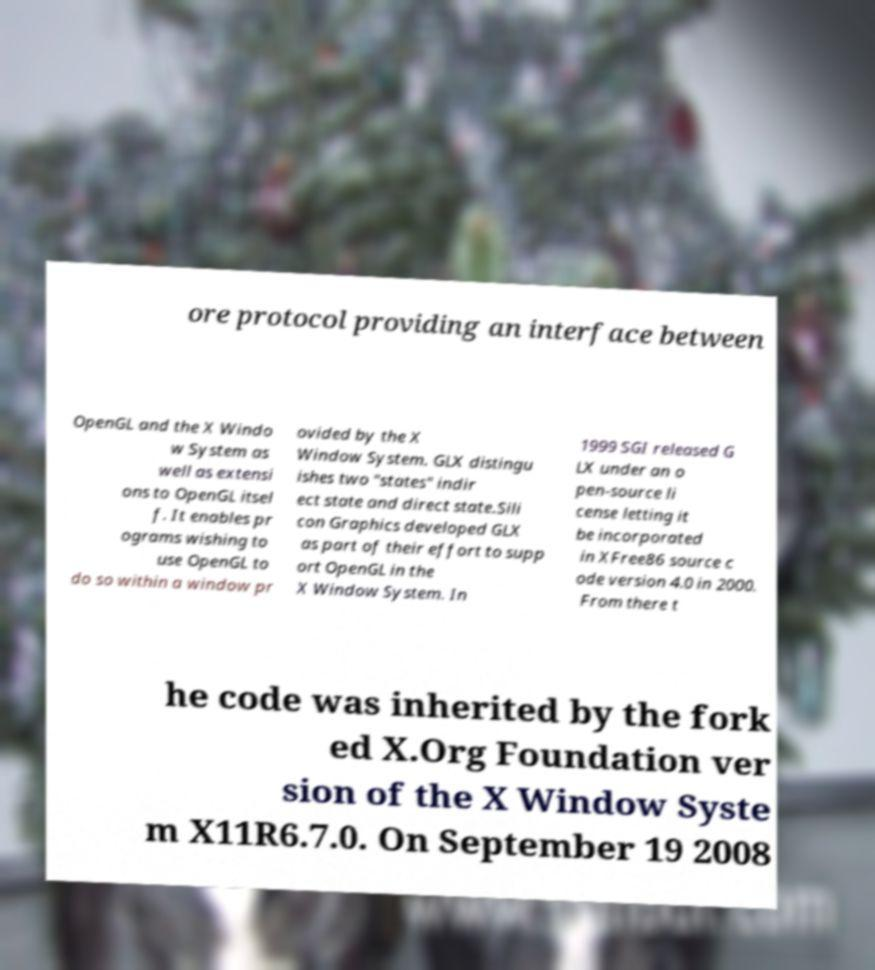What messages or text are displayed in this image? I need them in a readable, typed format. ore protocol providing an interface between OpenGL and the X Windo w System as well as extensi ons to OpenGL itsel f. It enables pr ograms wishing to use OpenGL to do so within a window pr ovided by the X Window System. GLX distingu ishes two "states" indir ect state and direct state.Sili con Graphics developed GLX as part of their effort to supp ort OpenGL in the X Window System. In 1999 SGI released G LX under an o pen-source li cense letting it be incorporated in XFree86 source c ode version 4.0 in 2000. From there t he code was inherited by the fork ed X.Org Foundation ver sion of the X Window Syste m X11R6.7.0. On September 19 2008 